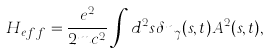Convert formula to latex. <formula><loc_0><loc_0><loc_500><loc_500>H _ { e f f } = \frac { e ^ { 2 } } { 2 m c ^ { 2 } } \int d ^ { 2 } s \delta n _ { \gamma } ( { s } , t ) { A } ^ { 2 } ( { s } , t ) ,</formula> 